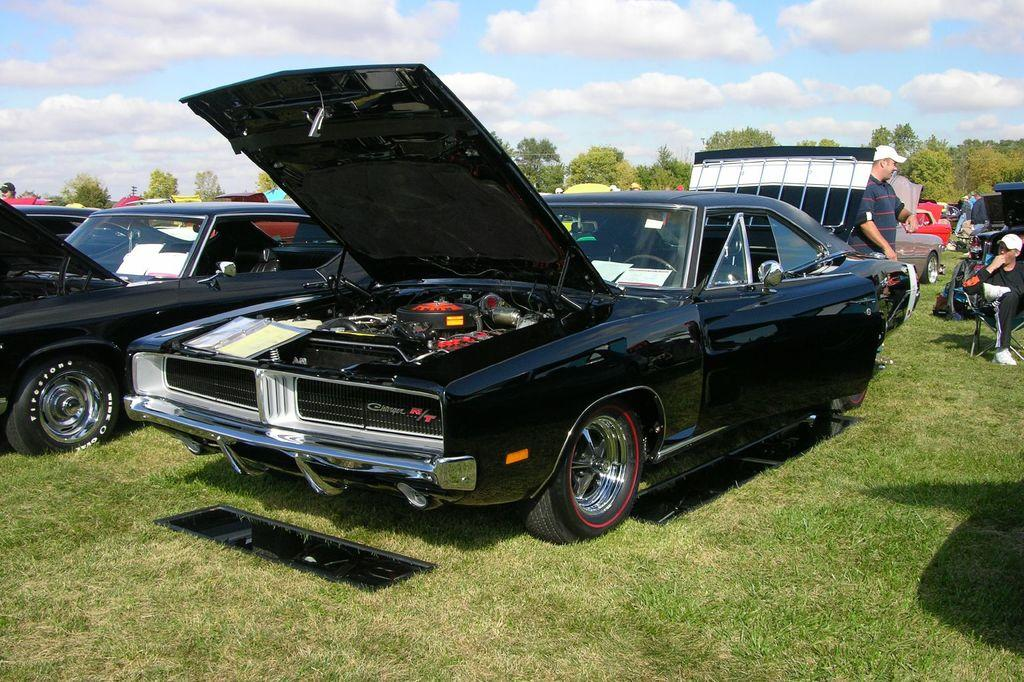What types of vehicles are in the image? There are vehicles in the image, but the specific types are not mentioned. What are the people on the ground doing in the image? The actions of the people on the ground are not specified. What type of vegetation is visible in the image? There is grass visible in the image. What else is present in the image besides vehicles and people? There are objects present in the image, but their nature is not described. What can be seen in the background of the image? There are trees and the sky visible in the background of the image. What is the condition of the sky in the image? The sky has clouds present in it. Can you tell me how many times the person on the ground coughs in the image? There is no mention of anyone coughing in the image. What type of crook is present in the image? There is no crook present in the image. 